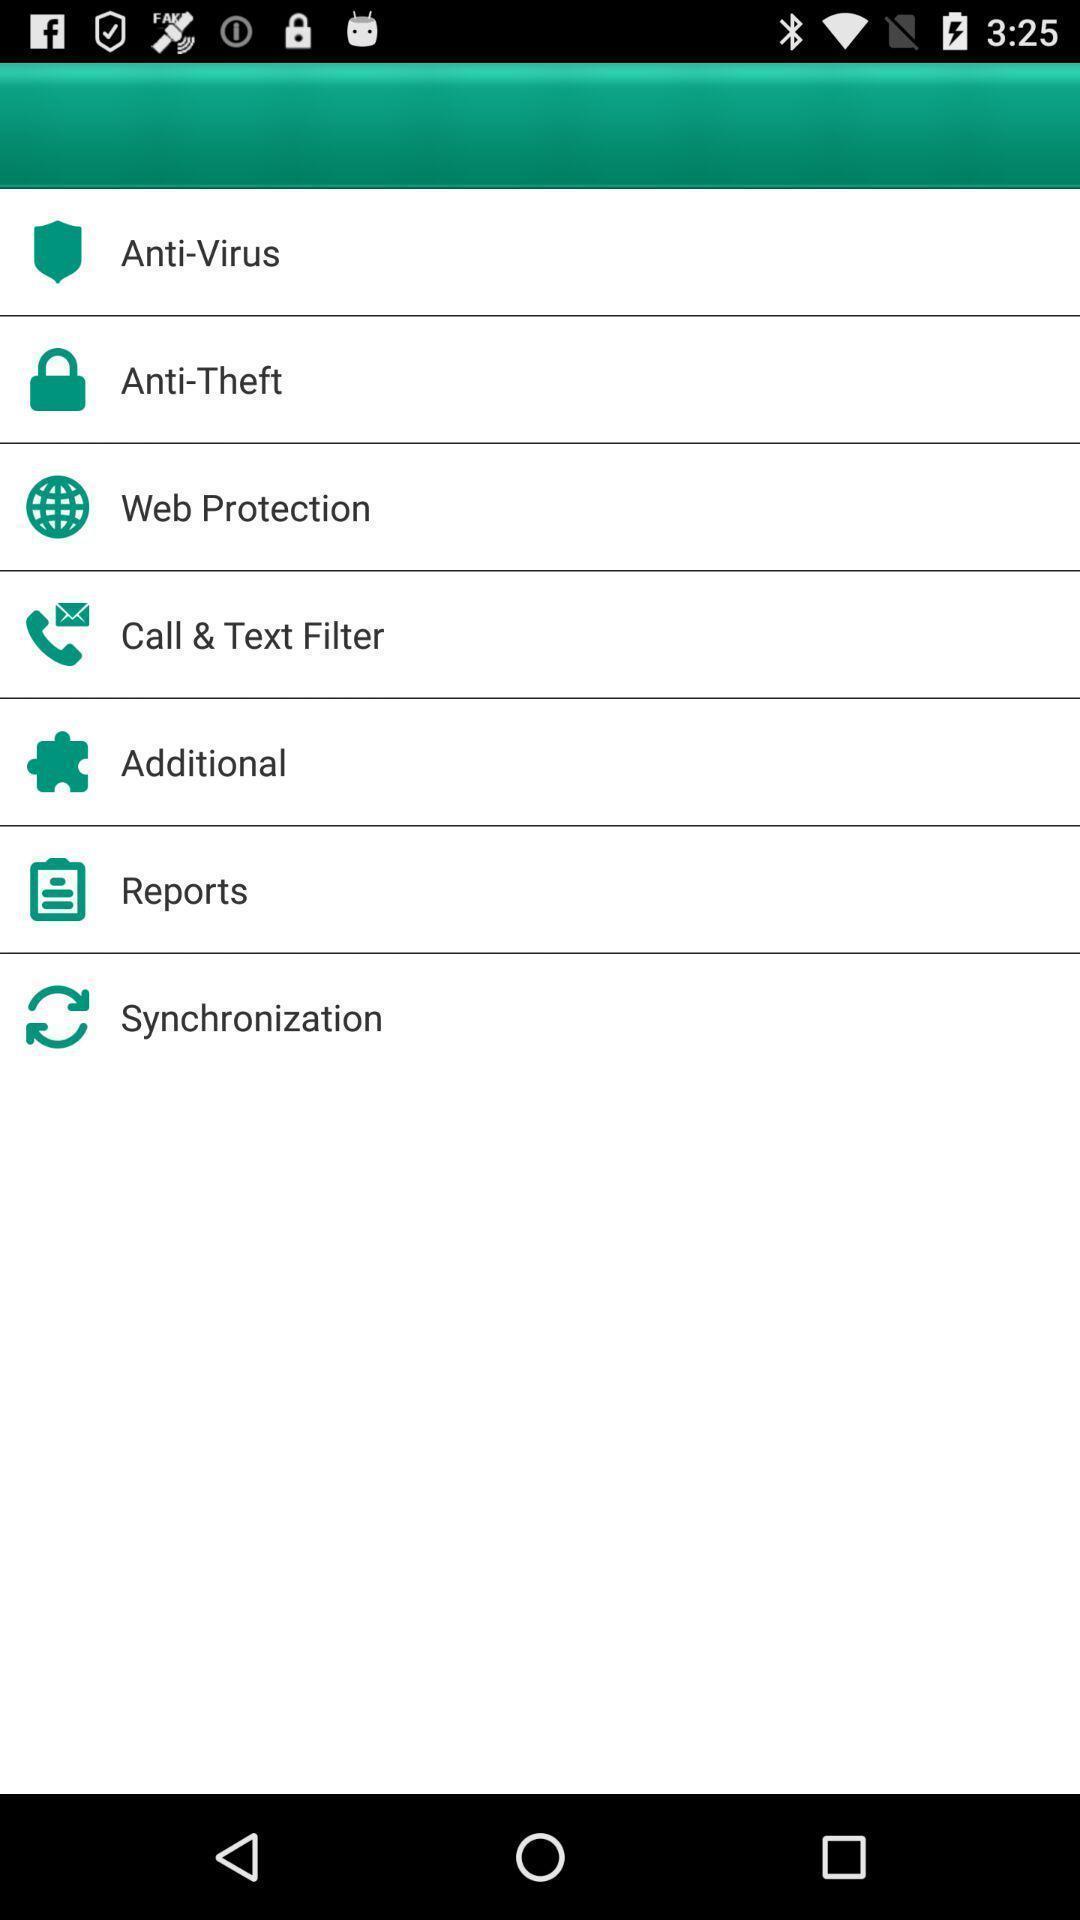Provide a textual representation of this image. Screen page displaying multiple protection options. 